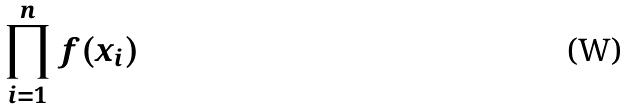<formula> <loc_0><loc_0><loc_500><loc_500>\prod _ { i = 1 } ^ { n } f ( x _ { i } )</formula> 